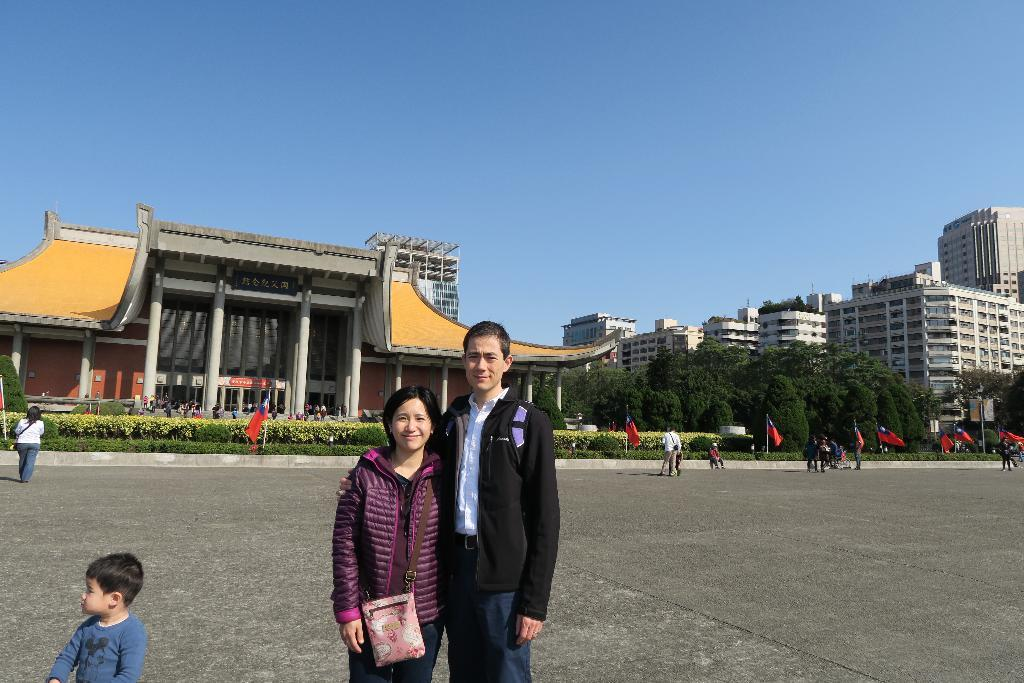What is happening on the road in the image? There are people on the road in the image. What can be seen in the image besides the people on the road? There are flags, garden plants, trees, and a building in the image. What is the purpose of the board attached to a pole in the image? The purpose of the board attached to a pole is not clear from the image, but it could be used for displaying information or advertisements. What is visible in the sky in the image? The sky is visible in the image. Can you see a unicorn jumping over a rainbow with a magic wand in the image? There is no unicorn, rainbow, or magic wand present in the image. 